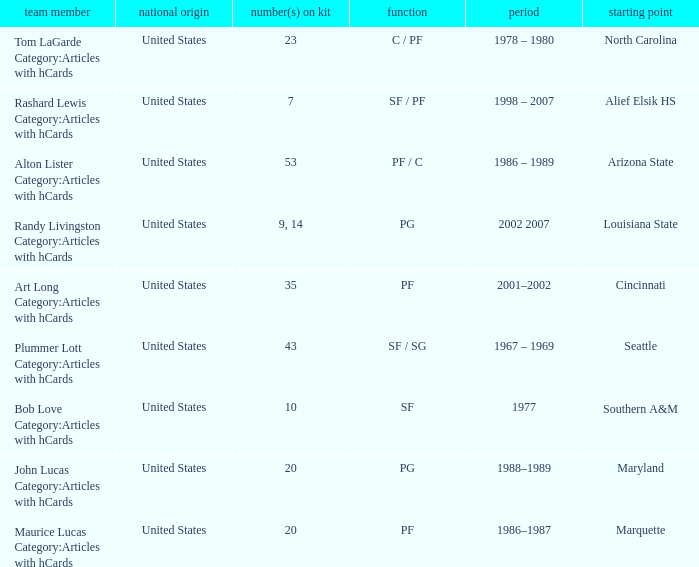Bob Love Category:Articles with hCards is from where? Southern A&M. 